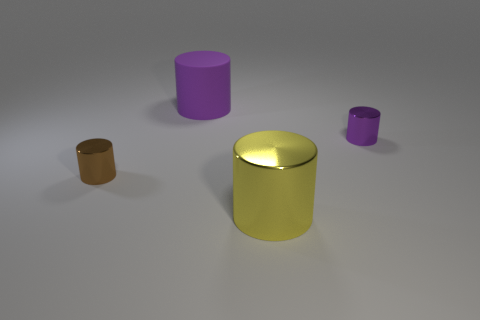Add 3 big cylinders. How many objects exist? 7 Subtract all large yellow metallic cylinders. How many cylinders are left? 3 Subtract 2 cylinders. How many cylinders are left? 2 Subtract all brown cylinders. How many cylinders are left? 3 Subtract all yellow cylinders. Subtract all blue blocks. How many cylinders are left? 3 Subtract all cyan balls. How many gray cylinders are left? 0 Subtract all rubber objects. Subtract all small brown things. How many objects are left? 2 Add 2 small shiny cylinders. How many small shiny cylinders are left? 4 Add 2 big things. How many big things exist? 4 Subtract 1 yellow cylinders. How many objects are left? 3 